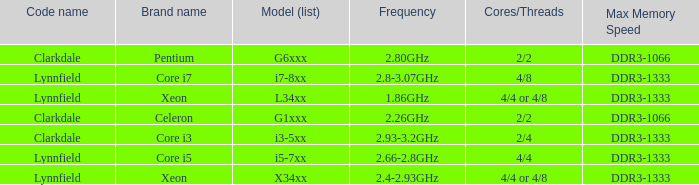What frequency does model L34xx use? 1.86GHz. 